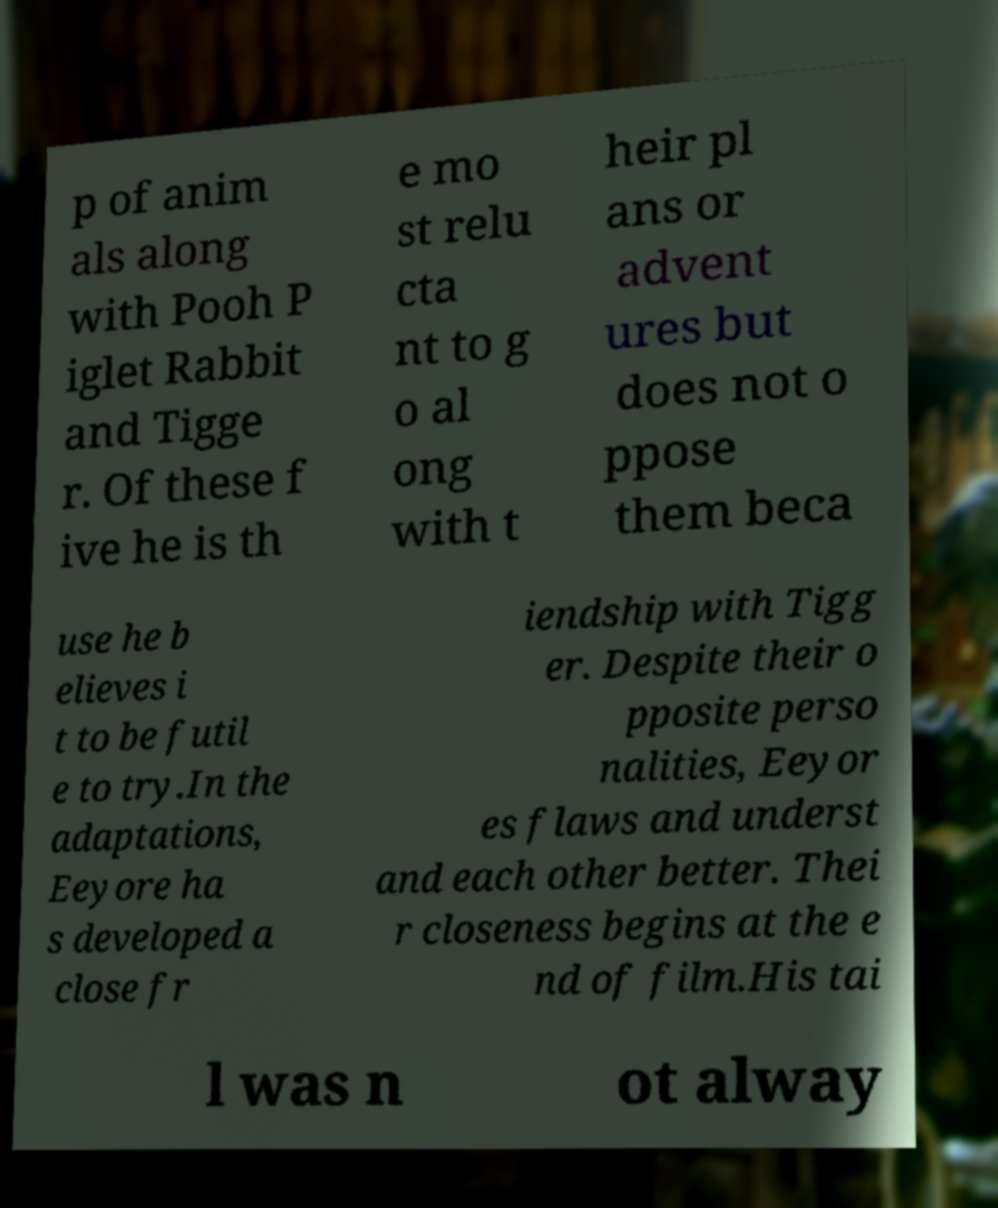What messages or text are displayed in this image? I need them in a readable, typed format. p of anim als along with Pooh P iglet Rabbit and Tigge r. Of these f ive he is th e mo st relu cta nt to g o al ong with t heir pl ans or advent ures but does not o ppose them beca use he b elieves i t to be futil e to try.In the adaptations, Eeyore ha s developed a close fr iendship with Tigg er. Despite their o pposite perso nalities, Eeyor es flaws and underst and each other better. Thei r closeness begins at the e nd of film.His tai l was n ot alway 